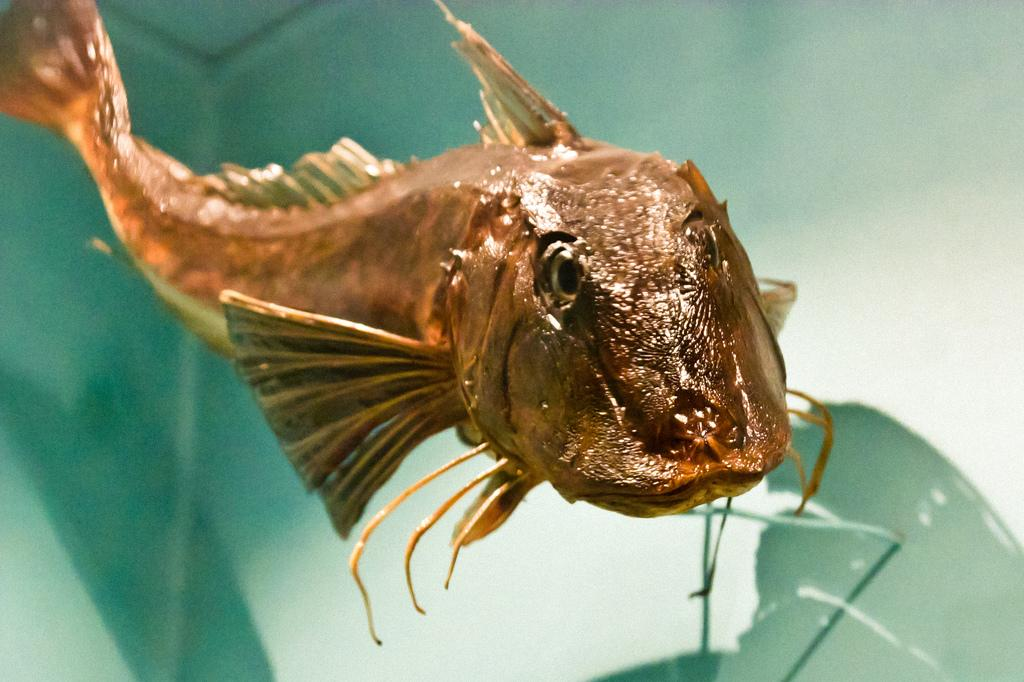What type of animal is in the image? There is a fish in the image. Where is the fish located? The fish is in water. What type of lumber is being used to build the pan in the image? There is no pan or lumber present in the image; it features a fish in water. 